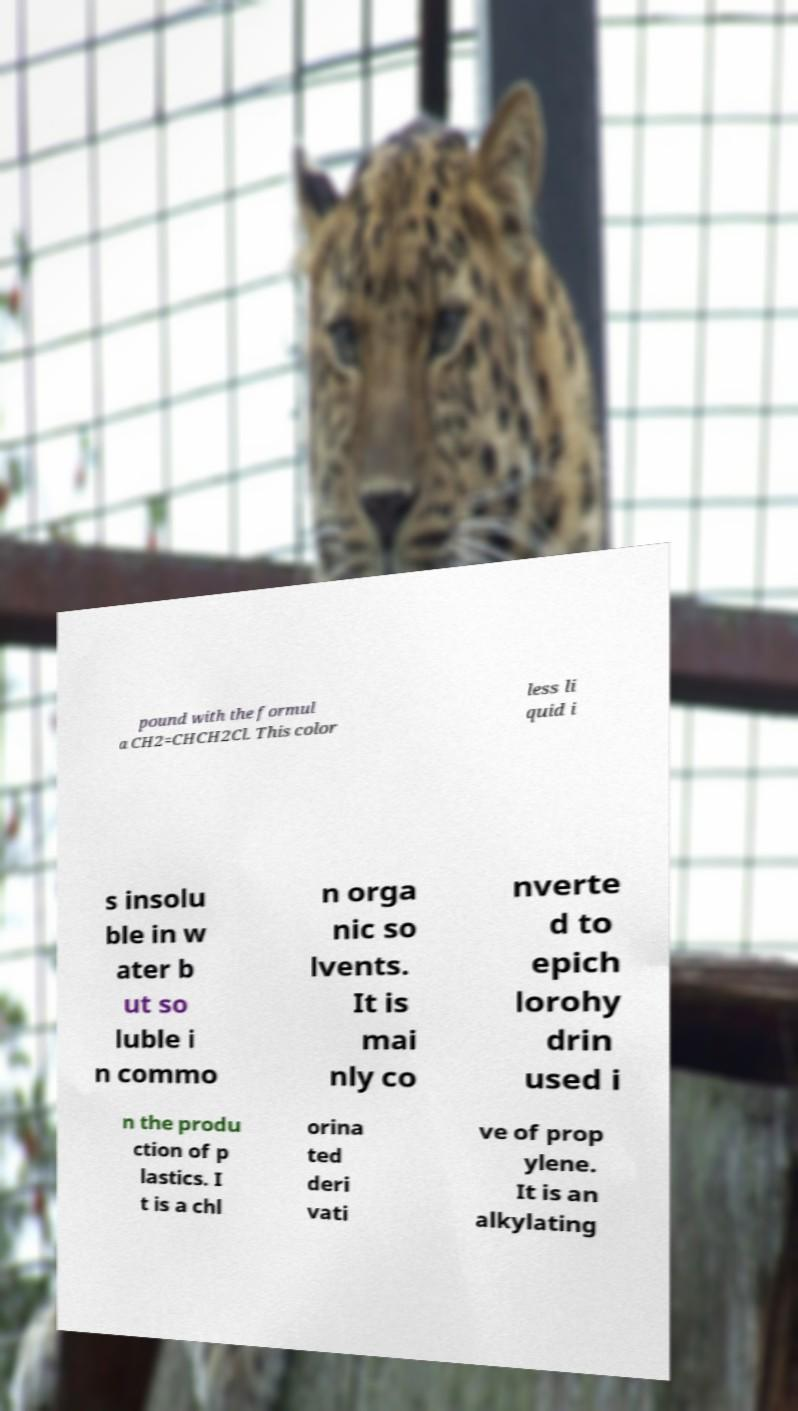Could you extract and type out the text from this image? pound with the formul a CH2=CHCH2Cl. This color less li quid i s insolu ble in w ater b ut so luble i n commo n orga nic so lvents. It is mai nly co nverte d to epich lorohy drin used i n the produ ction of p lastics. I t is a chl orina ted deri vati ve of prop ylene. It is an alkylating 